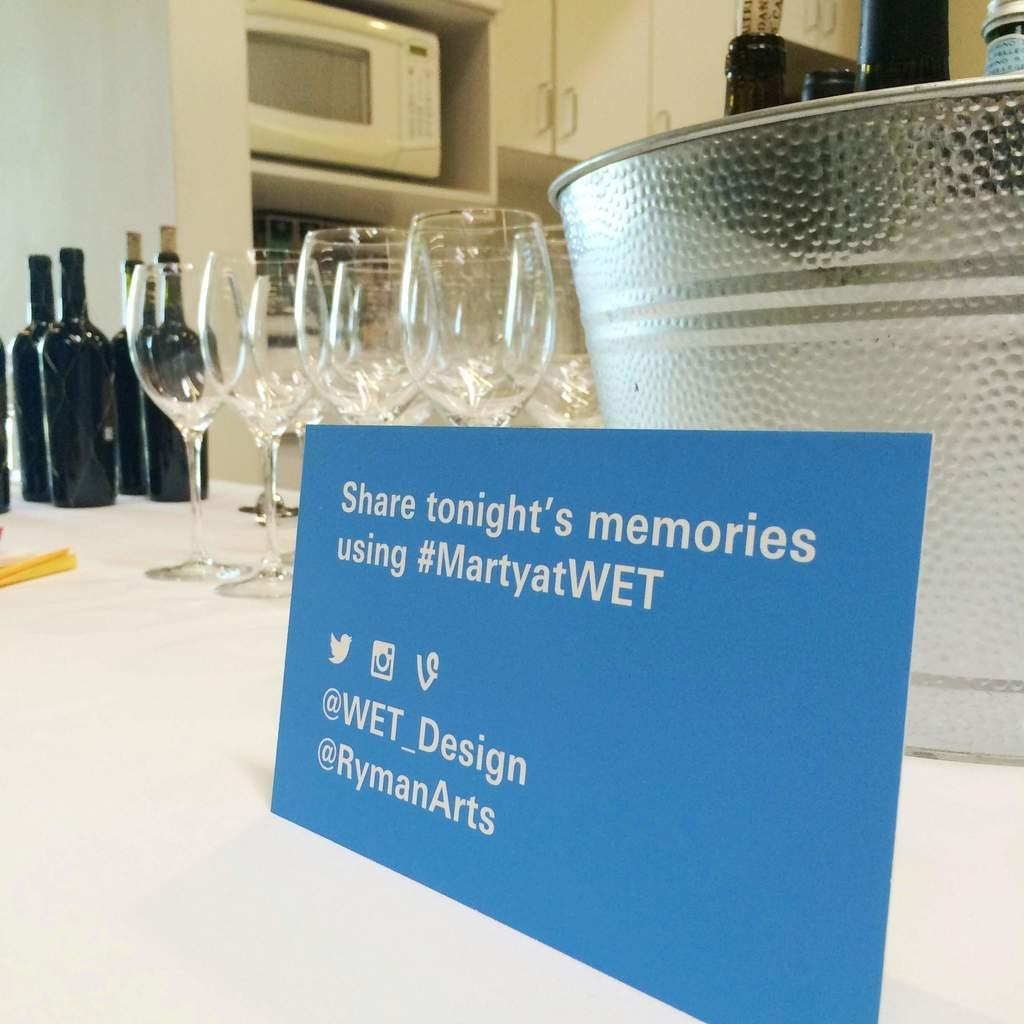Provide a one-sentence caption for the provided image. A table has wine glasses and wine bottles with a sign that says Share tonight's memories using #MartyatWET. 